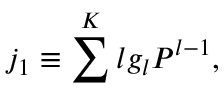Convert formula to latex. <formula><loc_0><loc_0><loc_500><loc_500>j _ { 1 } \equiv \sum ^ { K } l g _ { l } P ^ { l - 1 } ,</formula> 